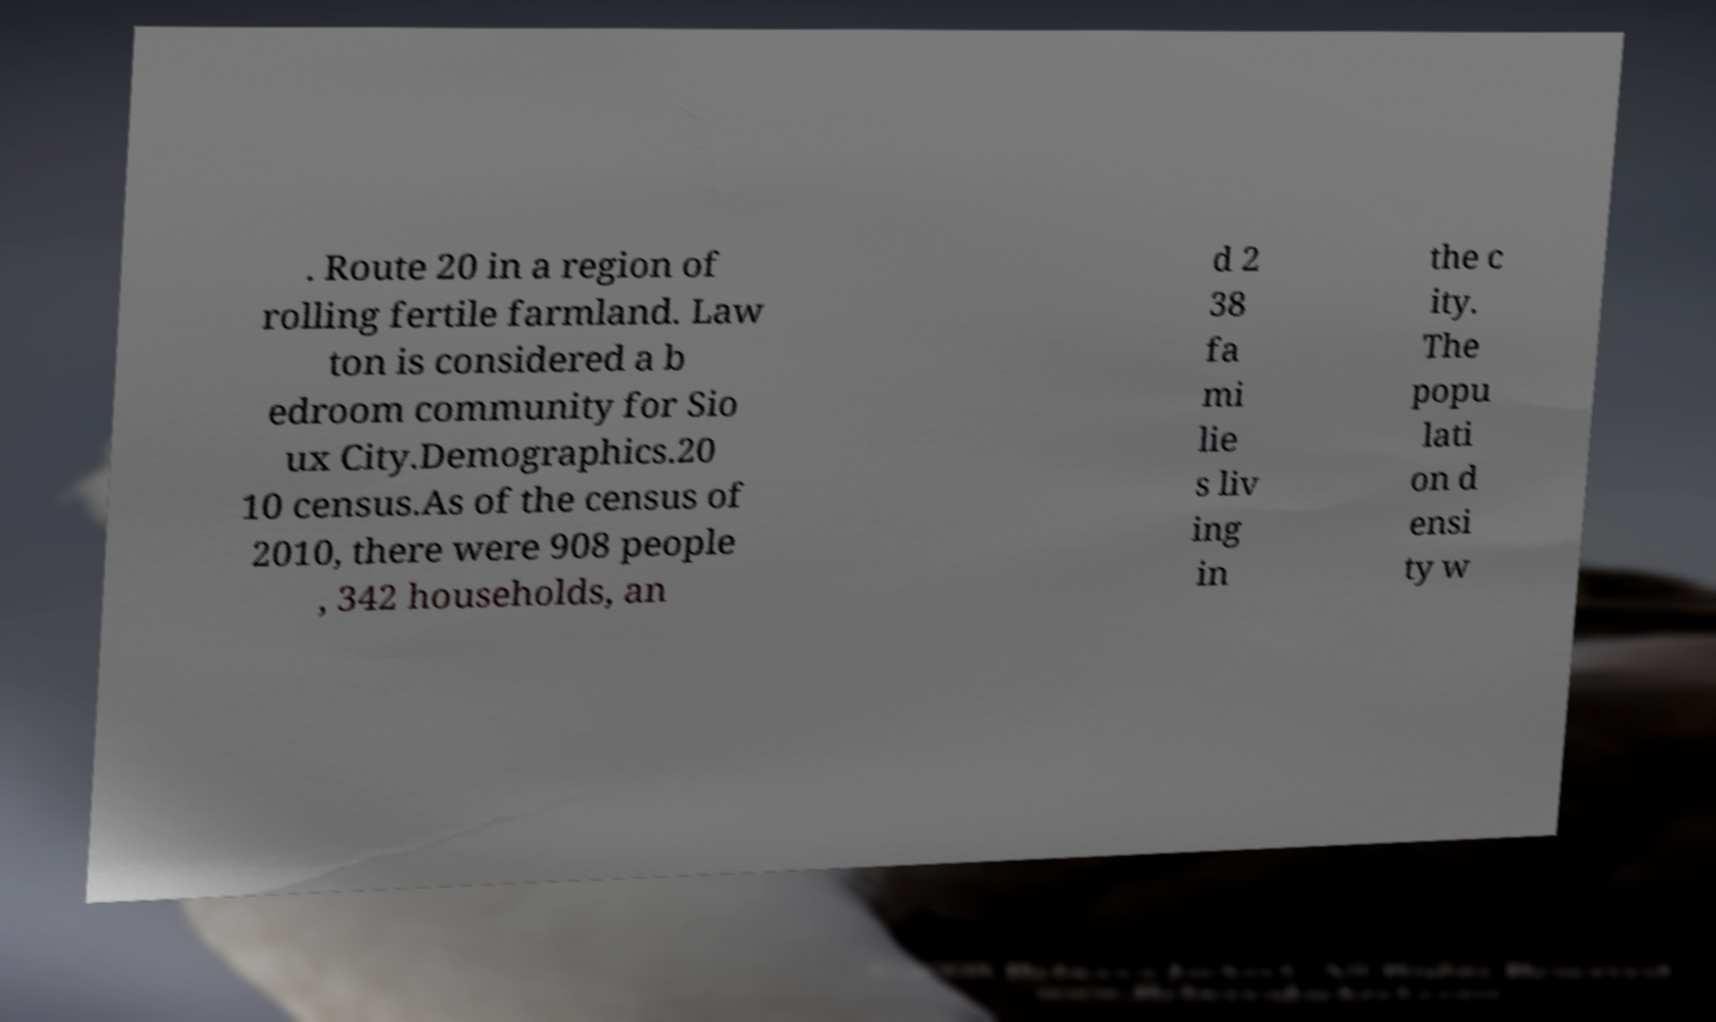Can you accurately transcribe the text from the provided image for me? . Route 20 in a region of rolling fertile farmland. Law ton is considered a b edroom community for Sio ux City.Demographics.20 10 census.As of the census of 2010, there were 908 people , 342 households, an d 2 38 fa mi lie s liv ing in the c ity. The popu lati on d ensi ty w 